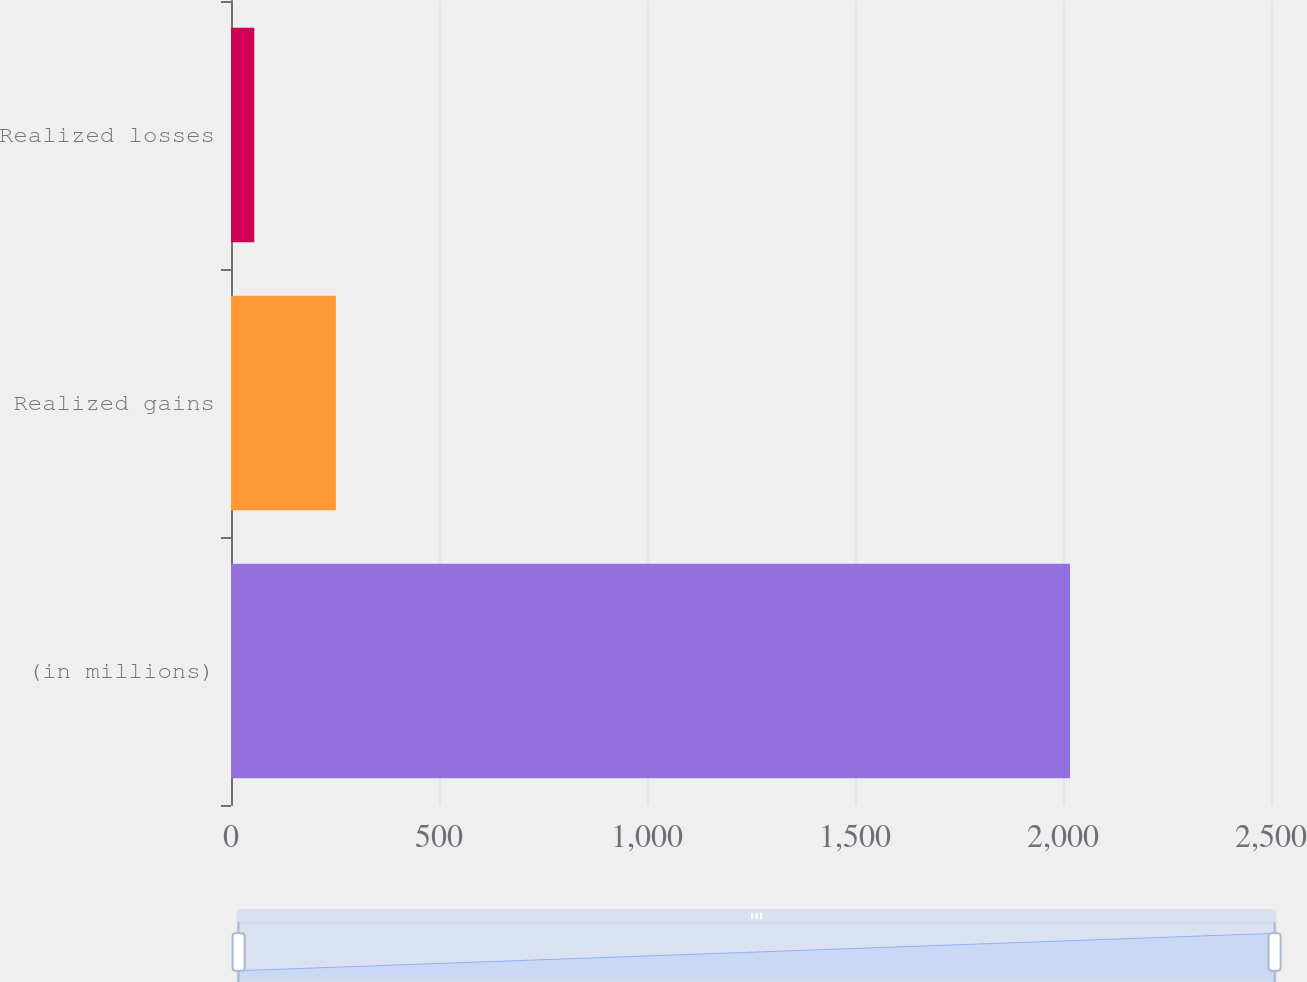<chart> <loc_0><loc_0><loc_500><loc_500><bar_chart><fcel>(in millions)<fcel>Realized gains<fcel>Realized losses<nl><fcel>2017<fcel>252.1<fcel>56<nl></chart> 